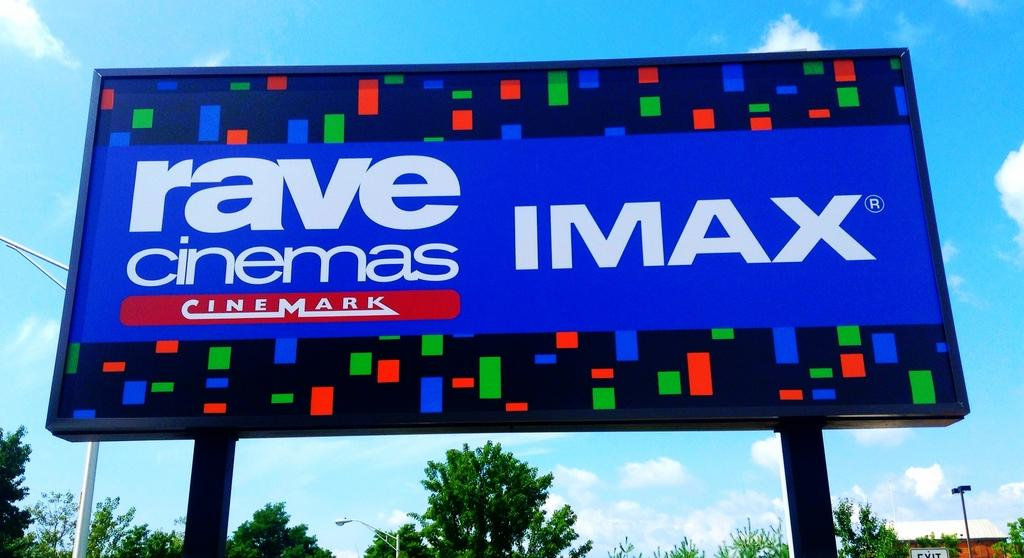<image>
Render a clear and concise summary of the photo. A colorful billboard promotes IMax at the Rave Cinemas. 